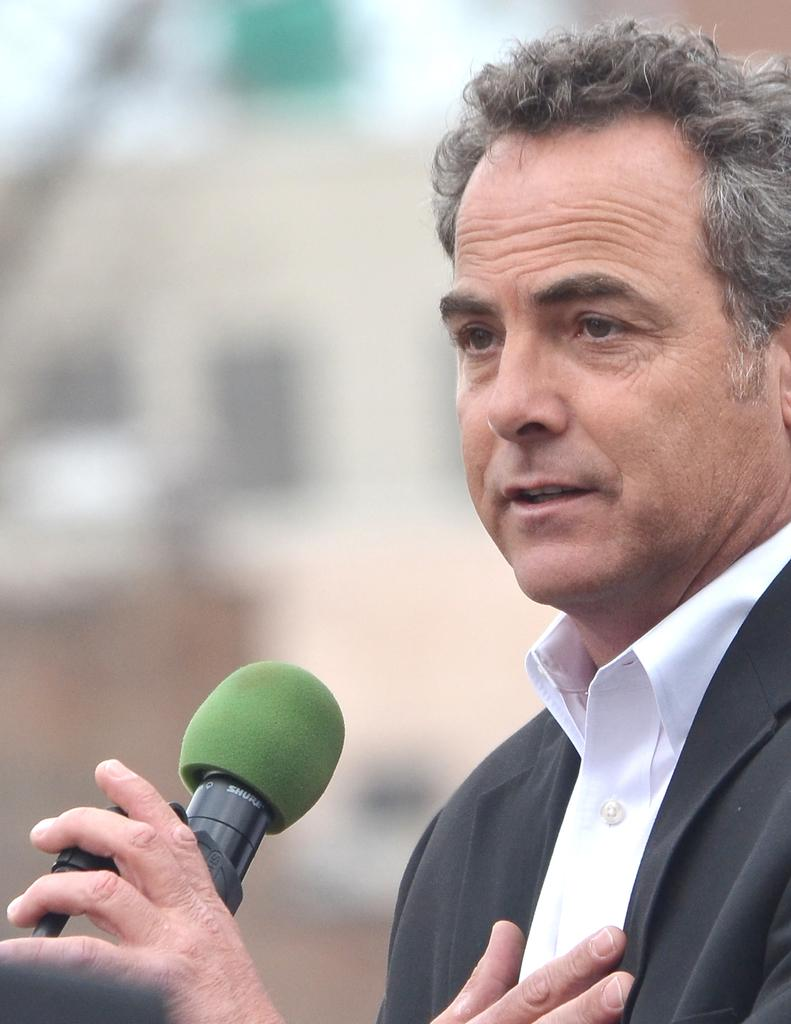What is the main subject of the image? There is a person in the image. What is the person holding in the image? The person is holding a microphone. Can you describe the background of the image? The background of the image is blurred. What type of passenger is the person in the image? The image does not depict a passenger or any transportation context, so it is not possible to determine if the person is a passenger. 